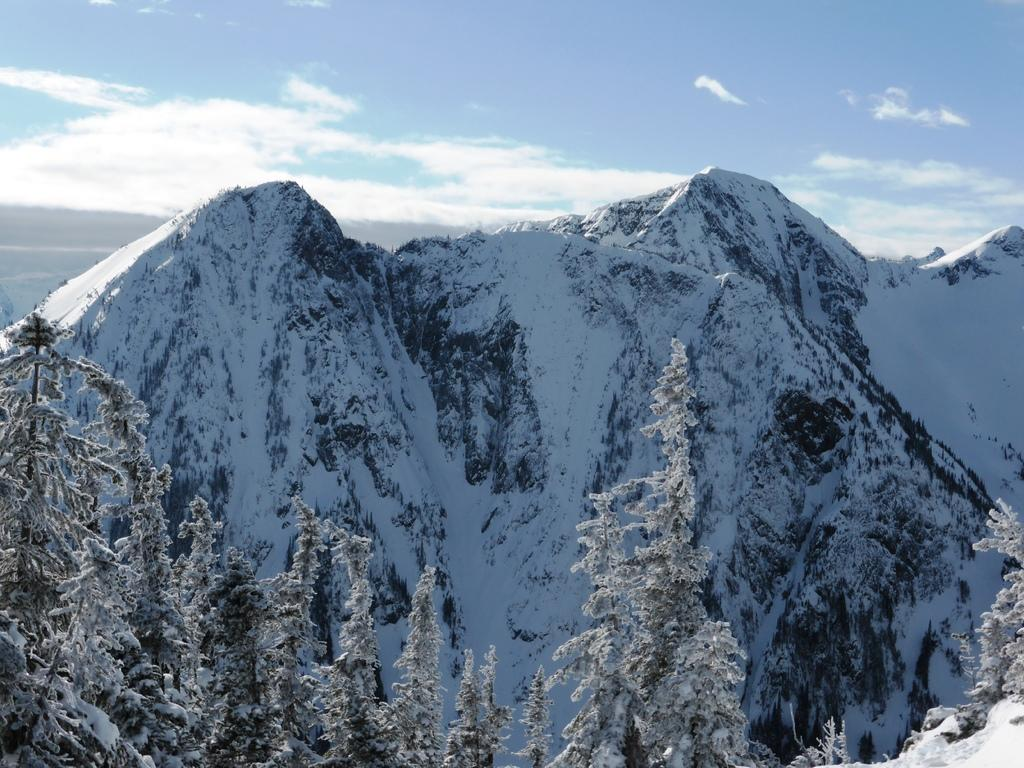What type of vegetation can be seen in the image? There are trees in the image. What is covering the trees in the image? The trees are covered with snow. What can be seen in the background of the image? There are mountains in the background of the image. How are the mountains depicted in the image? The mountains have snow all over them. What is visible above the trees and mountains in the image? The sky is visible in the image. What is present in the sky in the image? Clouds are present in the sky. What color is the crayon used to draw the mountains in the image? There is no crayon present in the image; it is a photograph of real mountains and trees. Can you tell me how much juice is left in the bottle in the image? There is no bottle of juice present in the image. 